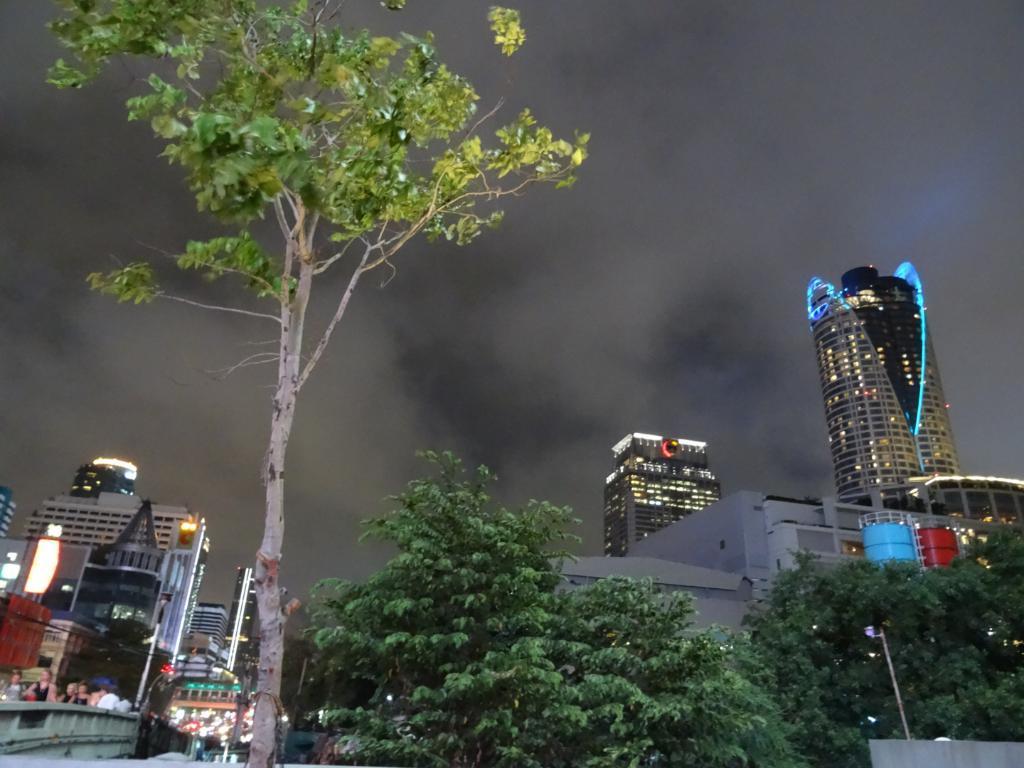In one or two sentences, can you explain what this image depicts? In this image there is the sky truncated towards the top of the image, there are buildings truncated towards the left of the image, there are buildings truncated towards the right of the image, there are trees truncated towards the bottom of the image, there are trees truncated towards the right of the image, there is a tree truncated towards the top of the image, there is an object truncated towards the bottom of the image. 